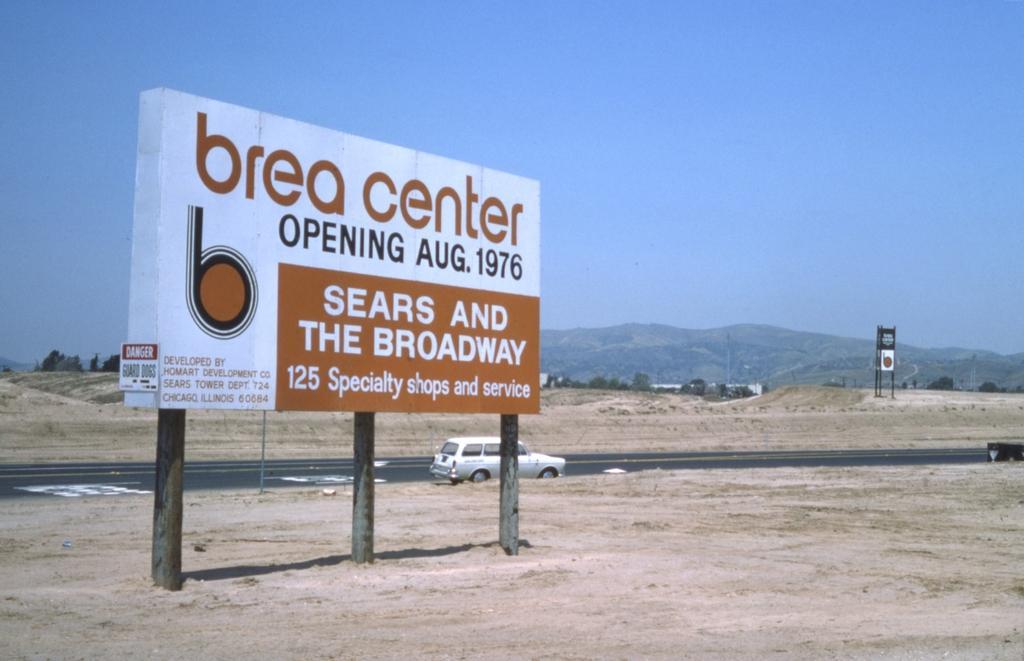Could you give a brief overview of what you see in this image? In this picture we can see a hoarding and we can find some text on it, behind the hoarding we can see a car on the road, in the background we can see few trees and hills. 